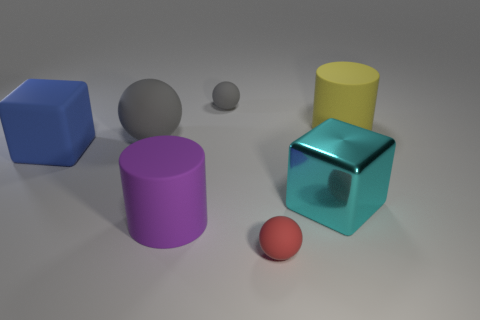What shape is the big object in front of the large metal block?
Offer a very short reply. Cylinder. What is the color of the metallic thing?
Your response must be concise. Cyan. What is the color of the big sphere that is the same material as the blue cube?
Provide a short and direct response. Gray. How many large blocks have the same material as the small red sphere?
Keep it short and to the point. 1. What number of gray objects are on the right side of the large gray ball?
Provide a short and direct response. 1. Do the gray thing in front of the big yellow rubber cylinder and the big cylinder that is on the right side of the cyan metal cube have the same material?
Keep it short and to the point. Yes. Are there more cylinders in front of the small red matte ball than gray balls that are behind the yellow cylinder?
Ensure brevity in your answer.  No. There is a small object that is the same color as the large rubber ball; what material is it?
Keep it short and to the point. Rubber. Is there any other thing that has the same shape as the blue thing?
Your answer should be compact. Yes. There is a large thing that is on the right side of the tiny gray rubber ball and in front of the big matte ball; what is its material?
Offer a very short reply. Metal. 